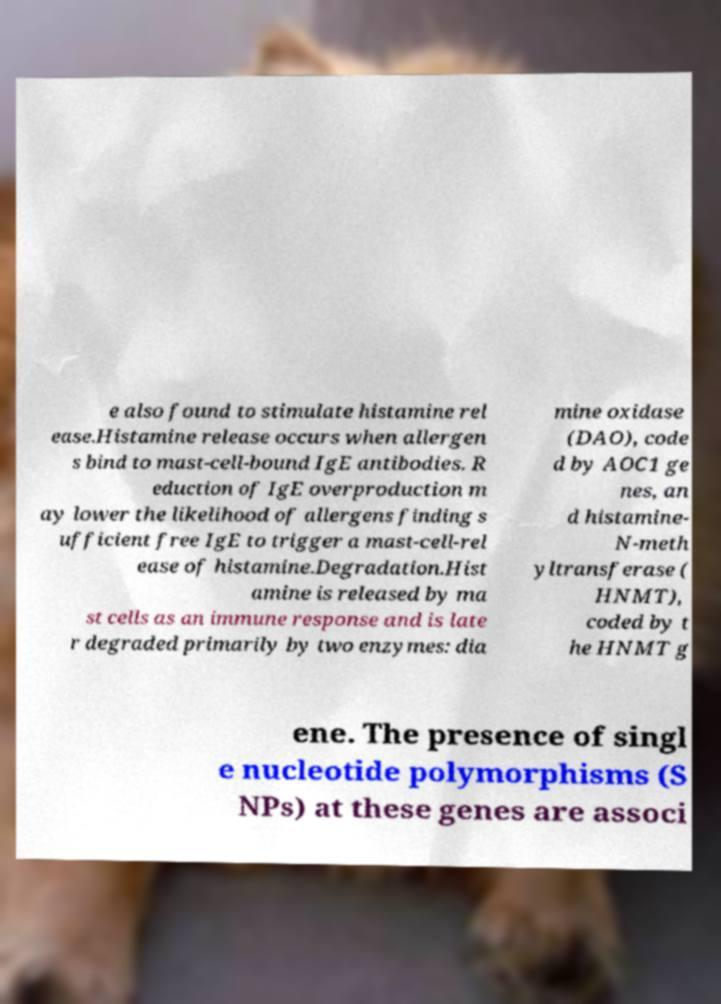What messages or text are displayed in this image? I need them in a readable, typed format. e also found to stimulate histamine rel ease.Histamine release occurs when allergen s bind to mast-cell-bound IgE antibodies. R eduction of IgE overproduction m ay lower the likelihood of allergens finding s ufficient free IgE to trigger a mast-cell-rel ease of histamine.Degradation.Hist amine is released by ma st cells as an immune response and is late r degraded primarily by two enzymes: dia mine oxidase (DAO), code d by AOC1 ge nes, an d histamine- N-meth yltransferase ( HNMT), coded by t he HNMT g ene. The presence of singl e nucleotide polymorphisms (S NPs) at these genes are associ 